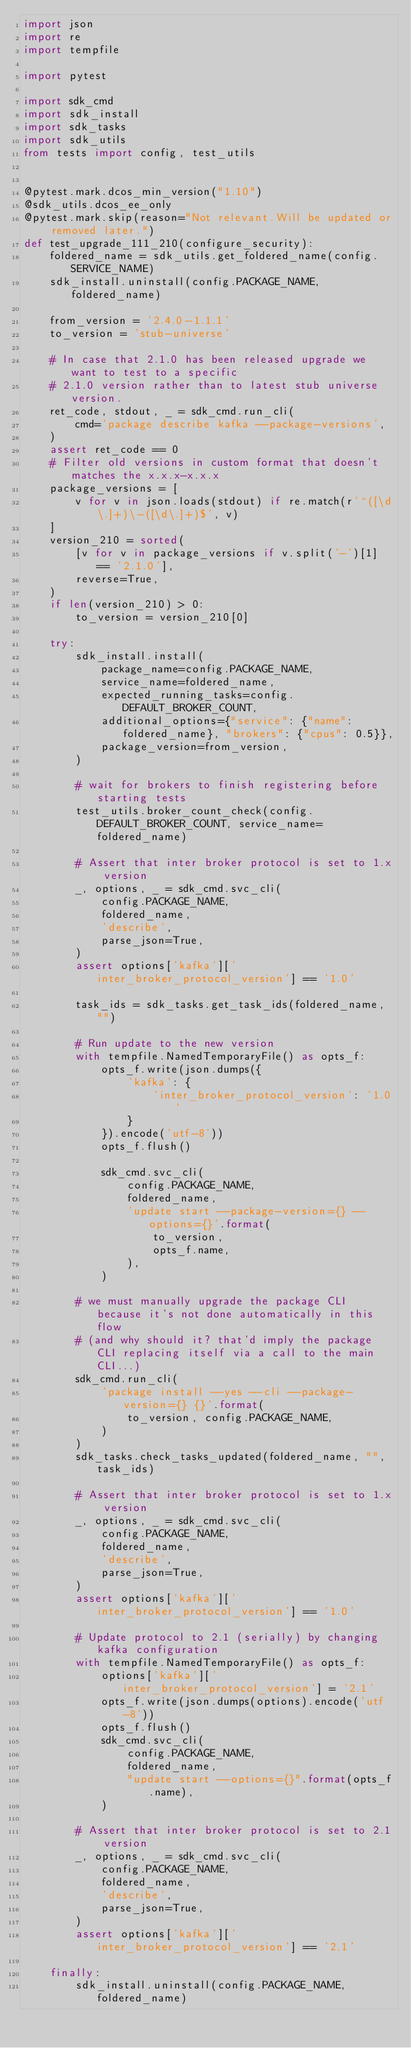Convert code to text. <code><loc_0><loc_0><loc_500><loc_500><_Python_>import json
import re
import tempfile

import pytest

import sdk_cmd
import sdk_install
import sdk_tasks
import sdk_utils
from tests import config, test_utils


@pytest.mark.dcos_min_version("1.10")
@sdk_utils.dcos_ee_only
@pytest.mark.skip(reason="Not relevant.Will be updated or removed later.")
def test_upgrade_111_210(configure_security):
    foldered_name = sdk_utils.get_foldered_name(config.SERVICE_NAME)
    sdk_install.uninstall(config.PACKAGE_NAME, foldered_name)

    from_version = '2.4.0-1.1.1'
    to_version = 'stub-universe'

    # In case that 2.1.0 has been released upgrade we want to test to a specific
    # 2.1.0 version rather than to latest stub universe version.
    ret_code, stdout, _ = sdk_cmd.run_cli(
        cmd='package describe kafka --package-versions',
    )
    assert ret_code == 0
    # Filter old versions in custom format that doesn't matches the x.x.x-x.x.x
    package_versions = [
        v for v in json.loads(stdout) if re.match(r'^([\d\.]+)\-([\d\.]+)$', v)
    ]
    version_210 = sorted(
        [v for v in package_versions if v.split('-')[1] == '2.1.0'],
        reverse=True,
    )
    if len(version_210) > 0:
        to_version = version_210[0]

    try:
        sdk_install.install(
            package_name=config.PACKAGE_NAME,
            service_name=foldered_name,
            expected_running_tasks=config.DEFAULT_BROKER_COUNT,
            additional_options={"service": {"name": foldered_name}, "brokers": {"cpus": 0.5}},
            package_version=from_version,
        )

        # wait for brokers to finish registering before starting tests
        test_utils.broker_count_check(config.DEFAULT_BROKER_COUNT, service_name=foldered_name)

        # Assert that inter broker protocol is set to 1.x version
        _, options, _ = sdk_cmd.svc_cli(
            config.PACKAGE_NAME,
            foldered_name,
            'describe',
            parse_json=True,
        )
        assert options['kafka']['inter_broker_protocol_version'] == '1.0'

        task_ids = sdk_tasks.get_task_ids(foldered_name, "")

        # Run update to the new version
        with tempfile.NamedTemporaryFile() as opts_f:
            opts_f.write(json.dumps({
                'kafka': {
                    'inter_broker_protocol_version': '1.0'
                }
            }).encode('utf-8'))
            opts_f.flush()

            sdk_cmd.svc_cli(
                config.PACKAGE_NAME,
                foldered_name,
                'update start --package-version={} --options={}'.format(
                    to_version,
                    opts_f.name,
                ),
            )

        # we must manually upgrade the package CLI because it's not done automatically in this flow
        # (and why should it? that'd imply the package CLI replacing itself via a call to the main CLI...)
        sdk_cmd.run_cli(
            'package install --yes --cli --package-version={} {}'.format(
                to_version, config.PACKAGE_NAME,
            )
        )
        sdk_tasks.check_tasks_updated(foldered_name, "", task_ids)

        # Assert that inter broker protocol is set to 1.x version
        _, options, _ = sdk_cmd.svc_cli(
            config.PACKAGE_NAME,
            foldered_name,
            'describe',
            parse_json=True,
        )
        assert options['kafka']['inter_broker_protocol_version'] == '1.0'

        # Update protocol to 2.1 (serially) by changing kafka configuration
        with tempfile.NamedTemporaryFile() as opts_f:
            options['kafka']['inter_broker_protocol_version'] = '2.1'
            opts_f.write(json.dumps(options).encode('utf-8'))
            opts_f.flush()
            sdk_cmd.svc_cli(
                config.PACKAGE_NAME,
                foldered_name,
                "update start --options={}".format(opts_f.name),
            )

        # Assert that inter broker protocol is set to 2.1 version
        _, options, _ = sdk_cmd.svc_cli(
            config.PACKAGE_NAME,
            foldered_name,
            'describe',
            parse_json=True,
        )
        assert options['kafka']['inter_broker_protocol_version'] == '2.1'

    finally:
        sdk_install.uninstall(config.PACKAGE_NAME, foldered_name)
</code> 